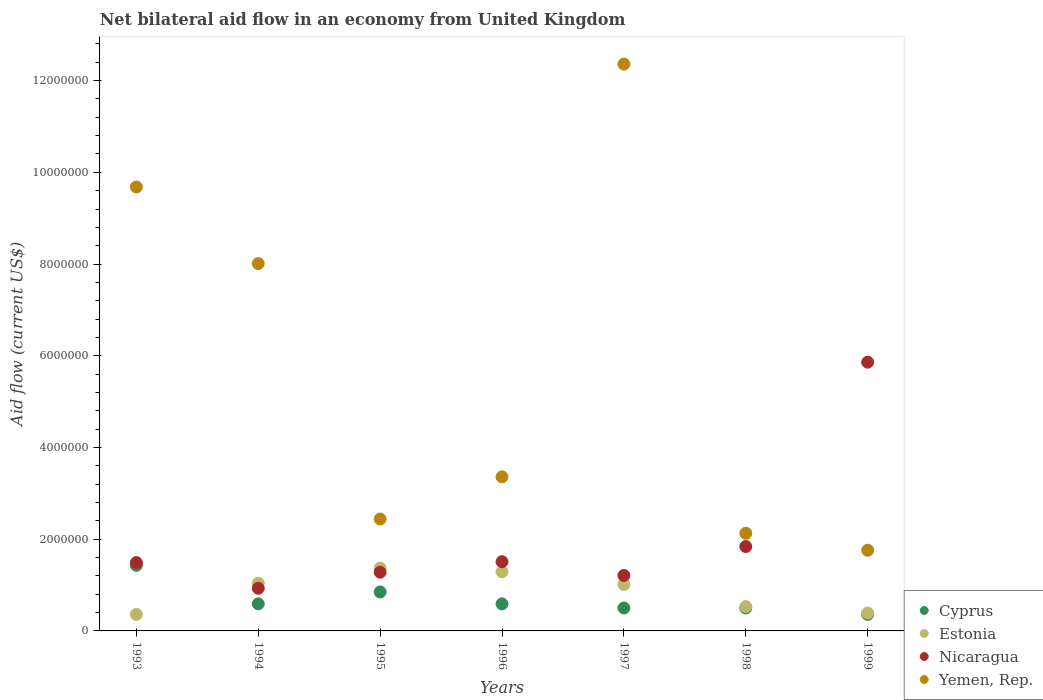How many different coloured dotlines are there?
Offer a terse response. 4. What is the net bilateral aid flow in Yemen, Rep. in 1997?
Offer a terse response. 1.24e+07. Across all years, what is the maximum net bilateral aid flow in Estonia?
Ensure brevity in your answer.  1.37e+06. In which year was the net bilateral aid flow in Estonia maximum?
Make the answer very short. 1995. In which year was the net bilateral aid flow in Yemen, Rep. minimum?
Your response must be concise. 1999. What is the total net bilateral aid flow in Cyprus in the graph?
Your answer should be compact. 4.82e+06. What is the difference between the net bilateral aid flow in Yemen, Rep. in 1996 and that in 1998?
Provide a short and direct response. 1.23e+06. What is the difference between the net bilateral aid flow in Nicaragua in 1998 and the net bilateral aid flow in Estonia in 1999?
Make the answer very short. 1.45e+06. What is the average net bilateral aid flow in Nicaragua per year?
Offer a very short reply. 2.02e+06. In the year 1995, what is the difference between the net bilateral aid flow in Nicaragua and net bilateral aid flow in Estonia?
Ensure brevity in your answer.  -9.00e+04. In how many years, is the net bilateral aid flow in Estonia greater than 1600000 US$?
Ensure brevity in your answer.  0. What is the ratio of the net bilateral aid flow in Yemen, Rep. in 1998 to that in 1999?
Provide a succinct answer. 1.21. Is the net bilateral aid flow in Nicaragua in 1993 less than that in 1997?
Offer a terse response. No. What is the difference between the highest and the second highest net bilateral aid flow in Cyprus?
Provide a succinct answer. 5.80e+05. What is the difference between the highest and the lowest net bilateral aid flow in Yemen, Rep.?
Keep it short and to the point. 1.06e+07. In how many years, is the net bilateral aid flow in Estonia greater than the average net bilateral aid flow in Estonia taken over all years?
Keep it short and to the point. 4. Is it the case that in every year, the sum of the net bilateral aid flow in Nicaragua and net bilateral aid flow in Cyprus  is greater than the sum of net bilateral aid flow in Yemen, Rep. and net bilateral aid flow in Estonia?
Ensure brevity in your answer.  No. Does the net bilateral aid flow in Cyprus monotonically increase over the years?
Give a very brief answer. No. Is the net bilateral aid flow in Estonia strictly greater than the net bilateral aid flow in Nicaragua over the years?
Keep it short and to the point. No. How many dotlines are there?
Give a very brief answer. 4. What is the difference between two consecutive major ticks on the Y-axis?
Your response must be concise. 2.00e+06. Are the values on the major ticks of Y-axis written in scientific E-notation?
Make the answer very short. No. Does the graph contain any zero values?
Your answer should be compact. No. Does the graph contain grids?
Provide a short and direct response. No. Where does the legend appear in the graph?
Your response must be concise. Bottom right. How many legend labels are there?
Keep it short and to the point. 4. How are the legend labels stacked?
Ensure brevity in your answer.  Vertical. What is the title of the graph?
Your response must be concise. Net bilateral aid flow in an economy from United Kingdom. Does "Small states" appear as one of the legend labels in the graph?
Provide a short and direct response. No. What is the label or title of the Y-axis?
Your answer should be very brief. Aid flow (current US$). What is the Aid flow (current US$) of Cyprus in 1993?
Provide a succinct answer. 1.43e+06. What is the Aid flow (current US$) in Estonia in 1993?
Keep it short and to the point. 3.60e+05. What is the Aid flow (current US$) of Nicaragua in 1993?
Make the answer very short. 1.49e+06. What is the Aid flow (current US$) in Yemen, Rep. in 1993?
Ensure brevity in your answer.  9.68e+06. What is the Aid flow (current US$) of Cyprus in 1994?
Provide a succinct answer. 5.90e+05. What is the Aid flow (current US$) in Estonia in 1994?
Your response must be concise. 1.04e+06. What is the Aid flow (current US$) in Nicaragua in 1994?
Offer a terse response. 9.30e+05. What is the Aid flow (current US$) of Yemen, Rep. in 1994?
Give a very brief answer. 8.01e+06. What is the Aid flow (current US$) of Cyprus in 1995?
Offer a terse response. 8.50e+05. What is the Aid flow (current US$) in Estonia in 1995?
Your answer should be very brief. 1.37e+06. What is the Aid flow (current US$) of Nicaragua in 1995?
Provide a succinct answer. 1.28e+06. What is the Aid flow (current US$) in Yemen, Rep. in 1995?
Make the answer very short. 2.44e+06. What is the Aid flow (current US$) in Cyprus in 1996?
Your response must be concise. 5.90e+05. What is the Aid flow (current US$) of Estonia in 1996?
Provide a short and direct response. 1.29e+06. What is the Aid flow (current US$) of Nicaragua in 1996?
Your response must be concise. 1.51e+06. What is the Aid flow (current US$) in Yemen, Rep. in 1996?
Your response must be concise. 3.36e+06. What is the Aid flow (current US$) of Estonia in 1997?
Provide a succinct answer. 1.01e+06. What is the Aid flow (current US$) in Nicaragua in 1997?
Your answer should be very brief. 1.21e+06. What is the Aid flow (current US$) of Yemen, Rep. in 1997?
Offer a terse response. 1.24e+07. What is the Aid flow (current US$) in Estonia in 1998?
Offer a very short reply. 5.30e+05. What is the Aid flow (current US$) in Nicaragua in 1998?
Keep it short and to the point. 1.84e+06. What is the Aid flow (current US$) of Yemen, Rep. in 1998?
Make the answer very short. 2.13e+06. What is the Aid flow (current US$) of Cyprus in 1999?
Give a very brief answer. 3.60e+05. What is the Aid flow (current US$) of Nicaragua in 1999?
Give a very brief answer. 5.86e+06. What is the Aid flow (current US$) of Yemen, Rep. in 1999?
Your answer should be compact. 1.76e+06. Across all years, what is the maximum Aid flow (current US$) of Cyprus?
Your answer should be very brief. 1.43e+06. Across all years, what is the maximum Aid flow (current US$) of Estonia?
Keep it short and to the point. 1.37e+06. Across all years, what is the maximum Aid flow (current US$) of Nicaragua?
Your answer should be compact. 5.86e+06. Across all years, what is the maximum Aid flow (current US$) in Yemen, Rep.?
Give a very brief answer. 1.24e+07. Across all years, what is the minimum Aid flow (current US$) of Estonia?
Ensure brevity in your answer.  3.60e+05. Across all years, what is the minimum Aid flow (current US$) in Nicaragua?
Offer a very short reply. 9.30e+05. Across all years, what is the minimum Aid flow (current US$) in Yemen, Rep.?
Give a very brief answer. 1.76e+06. What is the total Aid flow (current US$) of Cyprus in the graph?
Provide a short and direct response. 4.82e+06. What is the total Aid flow (current US$) in Estonia in the graph?
Offer a terse response. 5.99e+06. What is the total Aid flow (current US$) of Nicaragua in the graph?
Ensure brevity in your answer.  1.41e+07. What is the total Aid flow (current US$) of Yemen, Rep. in the graph?
Offer a very short reply. 3.97e+07. What is the difference between the Aid flow (current US$) in Cyprus in 1993 and that in 1994?
Your response must be concise. 8.40e+05. What is the difference between the Aid flow (current US$) of Estonia in 1993 and that in 1994?
Keep it short and to the point. -6.80e+05. What is the difference between the Aid flow (current US$) in Nicaragua in 1993 and that in 1994?
Your answer should be very brief. 5.60e+05. What is the difference between the Aid flow (current US$) of Yemen, Rep. in 1993 and that in 1994?
Your response must be concise. 1.67e+06. What is the difference between the Aid flow (current US$) in Cyprus in 1993 and that in 1995?
Give a very brief answer. 5.80e+05. What is the difference between the Aid flow (current US$) in Estonia in 1993 and that in 1995?
Provide a short and direct response. -1.01e+06. What is the difference between the Aid flow (current US$) of Nicaragua in 1993 and that in 1995?
Offer a terse response. 2.10e+05. What is the difference between the Aid flow (current US$) of Yemen, Rep. in 1993 and that in 1995?
Make the answer very short. 7.24e+06. What is the difference between the Aid flow (current US$) of Cyprus in 1993 and that in 1996?
Provide a short and direct response. 8.40e+05. What is the difference between the Aid flow (current US$) in Estonia in 1993 and that in 1996?
Keep it short and to the point. -9.30e+05. What is the difference between the Aid flow (current US$) of Nicaragua in 1993 and that in 1996?
Make the answer very short. -2.00e+04. What is the difference between the Aid flow (current US$) of Yemen, Rep. in 1993 and that in 1996?
Provide a short and direct response. 6.32e+06. What is the difference between the Aid flow (current US$) in Cyprus in 1993 and that in 1997?
Keep it short and to the point. 9.30e+05. What is the difference between the Aid flow (current US$) of Estonia in 1993 and that in 1997?
Make the answer very short. -6.50e+05. What is the difference between the Aid flow (current US$) in Nicaragua in 1993 and that in 1997?
Your answer should be very brief. 2.80e+05. What is the difference between the Aid flow (current US$) in Yemen, Rep. in 1993 and that in 1997?
Offer a very short reply. -2.68e+06. What is the difference between the Aid flow (current US$) in Cyprus in 1993 and that in 1998?
Give a very brief answer. 9.30e+05. What is the difference between the Aid flow (current US$) in Estonia in 1993 and that in 1998?
Your answer should be compact. -1.70e+05. What is the difference between the Aid flow (current US$) in Nicaragua in 1993 and that in 1998?
Ensure brevity in your answer.  -3.50e+05. What is the difference between the Aid flow (current US$) in Yemen, Rep. in 1993 and that in 1998?
Ensure brevity in your answer.  7.55e+06. What is the difference between the Aid flow (current US$) in Cyprus in 1993 and that in 1999?
Offer a very short reply. 1.07e+06. What is the difference between the Aid flow (current US$) in Nicaragua in 1993 and that in 1999?
Make the answer very short. -4.37e+06. What is the difference between the Aid flow (current US$) in Yemen, Rep. in 1993 and that in 1999?
Keep it short and to the point. 7.92e+06. What is the difference between the Aid flow (current US$) in Estonia in 1994 and that in 1995?
Give a very brief answer. -3.30e+05. What is the difference between the Aid flow (current US$) of Nicaragua in 1994 and that in 1995?
Your answer should be very brief. -3.50e+05. What is the difference between the Aid flow (current US$) of Yemen, Rep. in 1994 and that in 1995?
Keep it short and to the point. 5.57e+06. What is the difference between the Aid flow (current US$) of Estonia in 1994 and that in 1996?
Provide a short and direct response. -2.50e+05. What is the difference between the Aid flow (current US$) in Nicaragua in 1994 and that in 1996?
Provide a succinct answer. -5.80e+05. What is the difference between the Aid flow (current US$) of Yemen, Rep. in 1994 and that in 1996?
Provide a succinct answer. 4.65e+06. What is the difference between the Aid flow (current US$) in Cyprus in 1994 and that in 1997?
Your answer should be very brief. 9.00e+04. What is the difference between the Aid flow (current US$) in Nicaragua in 1994 and that in 1997?
Keep it short and to the point. -2.80e+05. What is the difference between the Aid flow (current US$) of Yemen, Rep. in 1994 and that in 1997?
Offer a terse response. -4.35e+06. What is the difference between the Aid flow (current US$) of Cyprus in 1994 and that in 1998?
Provide a short and direct response. 9.00e+04. What is the difference between the Aid flow (current US$) in Estonia in 1994 and that in 1998?
Give a very brief answer. 5.10e+05. What is the difference between the Aid flow (current US$) in Nicaragua in 1994 and that in 1998?
Your response must be concise. -9.10e+05. What is the difference between the Aid flow (current US$) in Yemen, Rep. in 1994 and that in 1998?
Ensure brevity in your answer.  5.88e+06. What is the difference between the Aid flow (current US$) in Estonia in 1994 and that in 1999?
Provide a succinct answer. 6.50e+05. What is the difference between the Aid flow (current US$) in Nicaragua in 1994 and that in 1999?
Provide a short and direct response. -4.93e+06. What is the difference between the Aid flow (current US$) of Yemen, Rep. in 1994 and that in 1999?
Give a very brief answer. 6.25e+06. What is the difference between the Aid flow (current US$) of Estonia in 1995 and that in 1996?
Make the answer very short. 8.00e+04. What is the difference between the Aid flow (current US$) of Nicaragua in 1995 and that in 1996?
Your answer should be compact. -2.30e+05. What is the difference between the Aid flow (current US$) in Yemen, Rep. in 1995 and that in 1996?
Your response must be concise. -9.20e+05. What is the difference between the Aid flow (current US$) of Cyprus in 1995 and that in 1997?
Give a very brief answer. 3.50e+05. What is the difference between the Aid flow (current US$) in Nicaragua in 1995 and that in 1997?
Offer a terse response. 7.00e+04. What is the difference between the Aid flow (current US$) in Yemen, Rep. in 1995 and that in 1997?
Your response must be concise. -9.92e+06. What is the difference between the Aid flow (current US$) in Cyprus in 1995 and that in 1998?
Your response must be concise. 3.50e+05. What is the difference between the Aid flow (current US$) in Estonia in 1995 and that in 1998?
Your answer should be very brief. 8.40e+05. What is the difference between the Aid flow (current US$) of Nicaragua in 1995 and that in 1998?
Your answer should be very brief. -5.60e+05. What is the difference between the Aid flow (current US$) in Cyprus in 1995 and that in 1999?
Provide a succinct answer. 4.90e+05. What is the difference between the Aid flow (current US$) of Estonia in 1995 and that in 1999?
Your answer should be compact. 9.80e+05. What is the difference between the Aid flow (current US$) of Nicaragua in 1995 and that in 1999?
Give a very brief answer. -4.58e+06. What is the difference between the Aid flow (current US$) of Yemen, Rep. in 1995 and that in 1999?
Give a very brief answer. 6.80e+05. What is the difference between the Aid flow (current US$) in Nicaragua in 1996 and that in 1997?
Provide a short and direct response. 3.00e+05. What is the difference between the Aid flow (current US$) of Yemen, Rep. in 1996 and that in 1997?
Keep it short and to the point. -9.00e+06. What is the difference between the Aid flow (current US$) in Estonia in 1996 and that in 1998?
Your answer should be compact. 7.60e+05. What is the difference between the Aid flow (current US$) of Nicaragua in 1996 and that in 1998?
Ensure brevity in your answer.  -3.30e+05. What is the difference between the Aid flow (current US$) of Yemen, Rep. in 1996 and that in 1998?
Provide a succinct answer. 1.23e+06. What is the difference between the Aid flow (current US$) in Estonia in 1996 and that in 1999?
Make the answer very short. 9.00e+05. What is the difference between the Aid flow (current US$) of Nicaragua in 1996 and that in 1999?
Make the answer very short. -4.35e+06. What is the difference between the Aid flow (current US$) of Yemen, Rep. in 1996 and that in 1999?
Your response must be concise. 1.60e+06. What is the difference between the Aid flow (current US$) of Nicaragua in 1997 and that in 1998?
Ensure brevity in your answer.  -6.30e+05. What is the difference between the Aid flow (current US$) of Yemen, Rep. in 1997 and that in 1998?
Provide a succinct answer. 1.02e+07. What is the difference between the Aid flow (current US$) of Cyprus in 1997 and that in 1999?
Your response must be concise. 1.40e+05. What is the difference between the Aid flow (current US$) in Estonia in 1997 and that in 1999?
Provide a short and direct response. 6.20e+05. What is the difference between the Aid flow (current US$) in Nicaragua in 1997 and that in 1999?
Offer a very short reply. -4.65e+06. What is the difference between the Aid flow (current US$) of Yemen, Rep. in 1997 and that in 1999?
Give a very brief answer. 1.06e+07. What is the difference between the Aid flow (current US$) of Cyprus in 1998 and that in 1999?
Make the answer very short. 1.40e+05. What is the difference between the Aid flow (current US$) in Nicaragua in 1998 and that in 1999?
Ensure brevity in your answer.  -4.02e+06. What is the difference between the Aid flow (current US$) in Yemen, Rep. in 1998 and that in 1999?
Offer a terse response. 3.70e+05. What is the difference between the Aid flow (current US$) of Cyprus in 1993 and the Aid flow (current US$) of Estonia in 1994?
Your response must be concise. 3.90e+05. What is the difference between the Aid flow (current US$) of Cyprus in 1993 and the Aid flow (current US$) of Yemen, Rep. in 1994?
Offer a very short reply. -6.58e+06. What is the difference between the Aid flow (current US$) of Estonia in 1993 and the Aid flow (current US$) of Nicaragua in 1994?
Your response must be concise. -5.70e+05. What is the difference between the Aid flow (current US$) of Estonia in 1993 and the Aid flow (current US$) of Yemen, Rep. in 1994?
Offer a very short reply. -7.65e+06. What is the difference between the Aid flow (current US$) of Nicaragua in 1993 and the Aid flow (current US$) of Yemen, Rep. in 1994?
Provide a succinct answer. -6.52e+06. What is the difference between the Aid flow (current US$) of Cyprus in 1993 and the Aid flow (current US$) of Yemen, Rep. in 1995?
Offer a very short reply. -1.01e+06. What is the difference between the Aid flow (current US$) of Estonia in 1993 and the Aid flow (current US$) of Nicaragua in 1995?
Offer a terse response. -9.20e+05. What is the difference between the Aid flow (current US$) of Estonia in 1993 and the Aid flow (current US$) of Yemen, Rep. in 1995?
Give a very brief answer. -2.08e+06. What is the difference between the Aid flow (current US$) in Nicaragua in 1993 and the Aid flow (current US$) in Yemen, Rep. in 1995?
Keep it short and to the point. -9.50e+05. What is the difference between the Aid flow (current US$) of Cyprus in 1993 and the Aid flow (current US$) of Nicaragua in 1996?
Your answer should be very brief. -8.00e+04. What is the difference between the Aid flow (current US$) of Cyprus in 1993 and the Aid flow (current US$) of Yemen, Rep. in 1996?
Keep it short and to the point. -1.93e+06. What is the difference between the Aid flow (current US$) of Estonia in 1993 and the Aid flow (current US$) of Nicaragua in 1996?
Provide a succinct answer. -1.15e+06. What is the difference between the Aid flow (current US$) in Estonia in 1993 and the Aid flow (current US$) in Yemen, Rep. in 1996?
Your answer should be very brief. -3.00e+06. What is the difference between the Aid flow (current US$) of Nicaragua in 1993 and the Aid flow (current US$) of Yemen, Rep. in 1996?
Ensure brevity in your answer.  -1.87e+06. What is the difference between the Aid flow (current US$) of Cyprus in 1993 and the Aid flow (current US$) of Estonia in 1997?
Make the answer very short. 4.20e+05. What is the difference between the Aid flow (current US$) of Cyprus in 1993 and the Aid flow (current US$) of Nicaragua in 1997?
Your response must be concise. 2.20e+05. What is the difference between the Aid flow (current US$) of Cyprus in 1993 and the Aid flow (current US$) of Yemen, Rep. in 1997?
Keep it short and to the point. -1.09e+07. What is the difference between the Aid flow (current US$) of Estonia in 1993 and the Aid flow (current US$) of Nicaragua in 1997?
Keep it short and to the point. -8.50e+05. What is the difference between the Aid flow (current US$) of Estonia in 1993 and the Aid flow (current US$) of Yemen, Rep. in 1997?
Your answer should be compact. -1.20e+07. What is the difference between the Aid flow (current US$) in Nicaragua in 1993 and the Aid flow (current US$) in Yemen, Rep. in 1997?
Provide a succinct answer. -1.09e+07. What is the difference between the Aid flow (current US$) in Cyprus in 1993 and the Aid flow (current US$) in Nicaragua in 1998?
Provide a short and direct response. -4.10e+05. What is the difference between the Aid flow (current US$) of Cyprus in 1993 and the Aid flow (current US$) of Yemen, Rep. in 1998?
Offer a terse response. -7.00e+05. What is the difference between the Aid flow (current US$) in Estonia in 1993 and the Aid flow (current US$) in Nicaragua in 1998?
Your answer should be compact. -1.48e+06. What is the difference between the Aid flow (current US$) in Estonia in 1993 and the Aid flow (current US$) in Yemen, Rep. in 1998?
Give a very brief answer. -1.77e+06. What is the difference between the Aid flow (current US$) of Nicaragua in 1993 and the Aid flow (current US$) of Yemen, Rep. in 1998?
Make the answer very short. -6.40e+05. What is the difference between the Aid flow (current US$) of Cyprus in 1993 and the Aid flow (current US$) of Estonia in 1999?
Offer a terse response. 1.04e+06. What is the difference between the Aid flow (current US$) of Cyprus in 1993 and the Aid flow (current US$) of Nicaragua in 1999?
Ensure brevity in your answer.  -4.43e+06. What is the difference between the Aid flow (current US$) in Cyprus in 1993 and the Aid flow (current US$) in Yemen, Rep. in 1999?
Provide a succinct answer. -3.30e+05. What is the difference between the Aid flow (current US$) of Estonia in 1993 and the Aid flow (current US$) of Nicaragua in 1999?
Your answer should be very brief. -5.50e+06. What is the difference between the Aid flow (current US$) in Estonia in 1993 and the Aid flow (current US$) in Yemen, Rep. in 1999?
Provide a succinct answer. -1.40e+06. What is the difference between the Aid flow (current US$) in Nicaragua in 1993 and the Aid flow (current US$) in Yemen, Rep. in 1999?
Make the answer very short. -2.70e+05. What is the difference between the Aid flow (current US$) of Cyprus in 1994 and the Aid flow (current US$) of Estonia in 1995?
Make the answer very short. -7.80e+05. What is the difference between the Aid flow (current US$) of Cyprus in 1994 and the Aid flow (current US$) of Nicaragua in 1995?
Your answer should be compact. -6.90e+05. What is the difference between the Aid flow (current US$) of Cyprus in 1994 and the Aid flow (current US$) of Yemen, Rep. in 1995?
Provide a short and direct response. -1.85e+06. What is the difference between the Aid flow (current US$) in Estonia in 1994 and the Aid flow (current US$) in Nicaragua in 1995?
Ensure brevity in your answer.  -2.40e+05. What is the difference between the Aid flow (current US$) of Estonia in 1994 and the Aid flow (current US$) of Yemen, Rep. in 1995?
Keep it short and to the point. -1.40e+06. What is the difference between the Aid flow (current US$) in Nicaragua in 1994 and the Aid flow (current US$) in Yemen, Rep. in 1995?
Provide a succinct answer. -1.51e+06. What is the difference between the Aid flow (current US$) of Cyprus in 1994 and the Aid flow (current US$) of Estonia in 1996?
Provide a short and direct response. -7.00e+05. What is the difference between the Aid flow (current US$) of Cyprus in 1994 and the Aid flow (current US$) of Nicaragua in 1996?
Make the answer very short. -9.20e+05. What is the difference between the Aid flow (current US$) in Cyprus in 1994 and the Aid flow (current US$) in Yemen, Rep. in 1996?
Your answer should be very brief. -2.77e+06. What is the difference between the Aid flow (current US$) in Estonia in 1994 and the Aid flow (current US$) in Nicaragua in 1996?
Your answer should be very brief. -4.70e+05. What is the difference between the Aid flow (current US$) of Estonia in 1994 and the Aid flow (current US$) of Yemen, Rep. in 1996?
Ensure brevity in your answer.  -2.32e+06. What is the difference between the Aid flow (current US$) in Nicaragua in 1994 and the Aid flow (current US$) in Yemen, Rep. in 1996?
Your response must be concise. -2.43e+06. What is the difference between the Aid flow (current US$) of Cyprus in 1994 and the Aid flow (current US$) of Estonia in 1997?
Offer a terse response. -4.20e+05. What is the difference between the Aid flow (current US$) in Cyprus in 1994 and the Aid flow (current US$) in Nicaragua in 1997?
Offer a very short reply. -6.20e+05. What is the difference between the Aid flow (current US$) of Cyprus in 1994 and the Aid flow (current US$) of Yemen, Rep. in 1997?
Keep it short and to the point. -1.18e+07. What is the difference between the Aid flow (current US$) of Estonia in 1994 and the Aid flow (current US$) of Nicaragua in 1997?
Your answer should be compact. -1.70e+05. What is the difference between the Aid flow (current US$) in Estonia in 1994 and the Aid flow (current US$) in Yemen, Rep. in 1997?
Provide a short and direct response. -1.13e+07. What is the difference between the Aid flow (current US$) in Nicaragua in 1994 and the Aid flow (current US$) in Yemen, Rep. in 1997?
Offer a terse response. -1.14e+07. What is the difference between the Aid flow (current US$) in Cyprus in 1994 and the Aid flow (current US$) in Nicaragua in 1998?
Your answer should be very brief. -1.25e+06. What is the difference between the Aid flow (current US$) in Cyprus in 1994 and the Aid flow (current US$) in Yemen, Rep. in 1998?
Offer a terse response. -1.54e+06. What is the difference between the Aid flow (current US$) of Estonia in 1994 and the Aid flow (current US$) of Nicaragua in 1998?
Make the answer very short. -8.00e+05. What is the difference between the Aid flow (current US$) of Estonia in 1994 and the Aid flow (current US$) of Yemen, Rep. in 1998?
Provide a short and direct response. -1.09e+06. What is the difference between the Aid flow (current US$) in Nicaragua in 1994 and the Aid flow (current US$) in Yemen, Rep. in 1998?
Make the answer very short. -1.20e+06. What is the difference between the Aid flow (current US$) in Cyprus in 1994 and the Aid flow (current US$) in Estonia in 1999?
Keep it short and to the point. 2.00e+05. What is the difference between the Aid flow (current US$) in Cyprus in 1994 and the Aid flow (current US$) in Nicaragua in 1999?
Make the answer very short. -5.27e+06. What is the difference between the Aid flow (current US$) of Cyprus in 1994 and the Aid flow (current US$) of Yemen, Rep. in 1999?
Your response must be concise. -1.17e+06. What is the difference between the Aid flow (current US$) in Estonia in 1994 and the Aid flow (current US$) in Nicaragua in 1999?
Offer a very short reply. -4.82e+06. What is the difference between the Aid flow (current US$) of Estonia in 1994 and the Aid flow (current US$) of Yemen, Rep. in 1999?
Give a very brief answer. -7.20e+05. What is the difference between the Aid flow (current US$) of Nicaragua in 1994 and the Aid flow (current US$) of Yemen, Rep. in 1999?
Provide a short and direct response. -8.30e+05. What is the difference between the Aid flow (current US$) of Cyprus in 1995 and the Aid flow (current US$) of Estonia in 1996?
Make the answer very short. -4.40e+05. What is the difference between the Aid flow (current US$) in Cyprus in 1995 and the Aid flow (current US$) in Nicaragua in 1996?
Provide a succinct answer. -6.60e+05. What is the difference between the Aid flow (current US$) in Cyprus in 1995 and the Aid flow (current US$) in Yemen, Rep. in 1996?
Your answer should be compact. -2.51e+06. What is the difference between the Aid flow (current US$) in Estonia in 1995 and the Aid flow (current US$) in Yemen, Rep. in 1996?
Your answer should be compact. -1.99e+06. What is the difference between the Aid flow (current US$) of Nicaragua in 1995 and the Aid flow (current US$) of Yemen, Rep. in 1996?
Keep it short and to the point. -2.08e+06. What is the difference between the Aid flow (current US$) of Cyprus in 1995 and the Aid flow (current US$) of Nicaragua in 1997?
Make the answer very short. -3.60e+05. What is the difference between the Aid flow (current US$) in Cyprus in 1995 and the Aid flow (current US$) in Yemen, Rep. in 1997?
Offer a terse response. -1.15e+07. What is the difference between the Aid flow (current US$) in Estonia in 1995 and the Aid flow (current US$) in Nicaragua in 1997?
Give a very brief answer. 1.60e+05. What is the difference between the Aid flow (current US$) in Estonia in 1995 and the Aid flow (current US$) in Yemen, Rep. in 1997?
Ensure brevity in your answer.  -1.10e+07. What is the difference between the Aid flow (current US$) of Nicaragua in 1995 and the Aid flow (current US$) of Yemen, Rep. in 1997?
Keep it short and to the point. -1.11e+07. What is the difference between the Aid flow (current US$) in Cyprus in 1995 and the Aid flow (current US$) in Nicaragua in 1998?
Your answer should be compact. -9.90e+05. What is the difference between the Aid flow (current US$) in Cyprus in 1995 and the Aid flow (current US$) in Yemen, Rep. in 1998?
Your answer should be compact. -1.28e+06. What is the difference between the Aid flow (current US$) of Estonia in 1995 and the Aid flow (current US$) of Nicaragua in 1998?
Provide a succinct answer. -4.70e+05. What is the difference between the Aid flow (current US$) of Estonia in 1995 and the Aid flow (current US$) of Yemen, Rep. in 1998?
Offer a very short reply. -7.60e+05. What is the difference between the Aid flow (current US$) of Nicaragua in 1995 and the Aid flow (current US$) of Yemen, Rep. in 1998?
Give a very brief answer. -8.50e+05. What is the difference between the Aid flow (current US$) of Cyprus in 1995 and the Aid flow (current US$) of Estonia in 1999?
Provide a short and direct response. 4.60e+05. What is the difference between the Aid flow (current US$) in Cyprus in 1995 and the Aid flow (current US$) in Nicaragua in 1999?
Your answer should be compact. -5.01e+06. What is the difference between the Aid flow (current US$) in Cyprus in 1995 and the Aid flow (current US$) in Yemen, Rep. in 1999?
Your answer should be compact. -9.10e+05. What is the difference between the Aid flow (current US$) in Estonia in 1995 and the Aid flow (current US$) in Nicaragua in 1999?
Your answer should be compact. -4.49e+06. What is the difference between the Aid flow (current US$) in Estonia in 1995 and the Aid flow (current US$) in Yemen, Rep. in 1999?
Offer a terse response. -3.90e+05. What is the difference between the Aid flow (current US$) of Nicaragua in 1995 and the Aid flow (current US$) of Yemen, Rep. in 1999?
Provide a short and direct response. -4.80e+05. What is the difference between the Aid flow (current US$) in Cyprus in 1996 and the Aid flow (current US$) in Estonia in 1997?
Make the answer very short. -4.20e+05. What is the difference between the Aid flow (current US$) in Cyprus in 1996 and the Aid flow (current US$) in Nicaragua in 1997?
Your answer should be very brief. -6.20e+05. What is the difference between the Aid flow (current US$) of Cyprus in 1996 and the Aid flow (current US$) of Yemen, Rep. in 1997?
Ensure brevity in your answer.  -1.18e+07. What is the difference between the Aid flow (current US$) of Estonia in 1996 and the Aid flow (current US$) of Nicaragua in 1997?
Offer a terse response. 8.00e+04. What is the difference between the Aid flow (current US$) in Estonia in 1996 and the Aid flow (current US$) in Yemen, Rep. in 1997?
Keep it short and to the point. -1.11e+07. What is the difference between the Aid flow (current US$) in Nicaragua in 1996 and the Aid flow (current US$) in Yemen, Rep. in 1997?
Offer a terse response. -1.08e+07. What is the difference between the Aid flow (current US$) in Cyprus in 1996 and the Aid flow (current US$) in Nicaragua in 1998?
Ensure brevity in your answer.  -1.25e+06. What is the difference between the Aid flow (current US$) of Cyprus in 1996 and the Aid flow (current US$) of Yemen, Rep. in 1998?
Keep it short and to the point. -1.54e+06. What is the difference between the Aid flow (current US$) in Estonia in 1996 and the Aid flow (current US$) in Nicaragua in 1998?
Offer a very short reply. -5.50e+05. What is the difference between the Aid flow (current US$) of Estonia in 1996 and the Aid flow (current US$) of Yemen, Rep. in 1998?
Your response must be concise. -8.40e+05. What is the difference between the Aid flow (current US$) in Nicaragua in 1996 and the Aid flow (current US$) in Yemen, Rep. in 1998?
Offer a very short reply. -6.20e+05. What is the difference between the Aid flow (current US$) in Cyprus in 1996 and the Aid flow (current US$) in Estonia in 1999?
Provide a short and direct response. 2.00e+05. What is the difference between the Aid flow (current US$) in Cyprus in 1996 and the Aid flow (current US$) in Nicaragua in 1999?
Offer a very short reply. -5.27e+06. What is the difference between the Aid flow (current US$) of Cyprus in 1996 and the Aid flow (current US$) of Yemen, Rep. in 1999?
Give a very brief answer. -1.17e+06. What is the difference between the Aid flow (current US$) of Estonia in 1996 and the Aid flow (current US$) of Nicaragua in 1999?
Provide a short and direct response. -4.57e+06. What is the difference between the Aid flow (current US$) in Estonia in 1996 and the Aid flow (current US$) in Yemen, Rep. in 1999?
Offer a terse response. -4.70e+05. What is the difference between the Aid flow (current US$) of Nicaragua in 1996 and the Aid flow (current US$) of Yemen, Rep. in 1999?
Provide a succinct answer. -2.50e+05. What is the difference between the Aid flow (current US$) of Cyprus in 1997 and the Aid flow (current US$) of Nicaragua in 1998?
Provide a succinct answer. -1.34e+06. What is the difference between the Aid flow (current US$) of Cyprus in 1997 and the Aid flow (current US$) of Yemen, Rep. in 1998?
Offer a very short reply. -1.63e+06. What is the difference between the Aid flow (current US$) in Estonia in 1997 and the Aid flow (current US$) in Nicaragua in 1998?
Your answer should be compact. -8.30e+05. What is the difference between the Aid flow (current US$) in Estonia in 1997 and the Aid flow (current US$) in Yemen, Rep. in 1998?
Provide a succinct answer. -1.12e+06. What is the difference between the Aid flow (current US$) in Nicaragua in 1997 and the Aid flow (current US$) in Yemen, Rep. in 1998?
Make the answer very short. -9.20e+05. What is the difference between the Aid flow (current US$) of Cyprus in 1997 and the Aid flow (current US$) of Nicaragua in 1999?
Provide a succinct answer. -5.36e+06. What is the difference between the Aid flow (current US$) in Cyprus in 1997 and the Aid flow (current US$) in Yemen, Rep. in 1999?
Your response must be concise. -1.26e+06. What is the difference between the Aid flow (current US$) of Estonia in 1997 and the Aid flow (current US$) of Nicaragua in 1999?
Give a very brief answer. -4.85e+06. What is the difference between the Aid flow (current US$) in Estonia in 1997 and the Aid flow (current US$) in Yemen, Rep. in 1999?
Offer a very short reply. -7.50e+05. What is the difference between the Aid flow (current US$) of Nicaragua in 1997 and the Aid flow (current US$) of Yemen, Rep. in 1999?
Offer a terse response. -5.50e+05. What is the difference between the Aid flow (current US$) of Cyprus in 1998 and the Aid flow (current US$) of Nicaragua in 1999?
Provide a succinct answer. -5.36e+06. What is the difference between the Aid flow (current US$) in Cyprus in 1998 and the Aid flow (current US$) in Yemen, Rep. in 1999?
Give a very brief answer. -1.26e+06. What is the difference between the Aid flow (current US$) in Estonia in 1998 and the Aid flow (current US$) in Nicaragua in 1999?
Provide a succinct answer. -5.33e+06. What is the difference between the Aid flow (current US$) of Estonia in 1998 and the Aid flow (current US$) of Yemen, Rep. in 1999?
Offer a very short reply. -1.23e+06. What is the difference between the Aid flow (current US$) in Nicaragua in 1998 and the Aid flow (current US$) in Yemen, Rep. in 1999?
Make the answer very short. 8.00e+04. What is the average Aid flow (current US$) of Cyprus per year?
Offer a terse response. 6.89e+05. What is the average Aid flow (current US$) of Estonia per year?
Offer a very short reply. 8.56e+05. What is the average Aid flow (current US$) in Nicaragua per year?
Offer a very short reply. 2.02e+06. What is the average Aid flow (current US$) in Yemen, Rep. per year?
Your response must be concise. 5.68e+06. In the year 1993, what is the difference between the Aid flow (current US$) of Cyprus and Aid flow (current US$) of Estonia?
Provide a succinct answer. 1.07e+06. In the year 1993, what is the difference between the Aid flow (current US$) in Cyprus and Aid flow (current US$) in Yemen, Rep.?
Your answer should be compact. -8.25e+06. In the year 1993, what is the difference between the Aid flow (current US$) in Estonia and Aid flow (current US$) in Nicaragua?
Give a very brief answer. -1.13e+06. In the year 1993, what is the difference between the Aid flow (current US$) in Estonia and Aid flow (current US$) in Yemen, Rep.?
Give a very brief answer. -9.32e+06. In the year 1993, what is the difference between the Aid flow (current US$) of Nicaragua and Aid flow (current US$) of Yemen, Rep.?
Ensure brevity in your answer.  -8.19e+06. In the year 1994, what is the difference between the Aid flow (current US$) in Cyprus and Aid flow (current US$) in Estonia?
Offer a very short reply. -4.50e+05. In the year 1994, what is the difference between the Aid flow (current US$) of Cyprus and Aid flow (current US$) of Nicaragua?
Provide a succinct answer. -3.40e+05. In the year 1994, what is the difference between the Aid flow (current US$) of Cyprus and Aid flow (current US$) of Yemen, Rep.?
Offer a terse response. -7.42e+06. In the year 1994, what is the difference between the Aid flow (current US$) in Estonia and Aid flow (current US$) in Yemen, Rep.?
Your answer should be very brief. -6.97e+06. In the year 1994, what is the difference between the Aid flow (current US$) of Nicaragua and Aid flow (current US$) of Yemen, Rep.?
Provide a succinct answer. -7.08e+06. In the year 1995, what is the difference between the Aid flow (current US$) of Cyprus and Aid flow (current US$) of Estonia?
Your answer should be very brief. -5.20e+05. In the year 1995, what is the difference between the Aid flow (current US$) in Cyprus and Aid flow (current US$) in Nicaragua?
Ensure brevity in your answer.  -4.30e+05. In the year 1995, what is the difference between the Aid flow (current US$) of Cyprus and Aid flow (current US$) of Yemen, Rep.?
Keep it short and to the point. -1.59e+06. In the year 1995, what is the difference between the Aid flow (current US$) in Estonia and Aid flow (current US$) in Nicaragua?
Provide a succinct answer. 9.00e+04. In the year 1995, what is the difference between the Aid flow (current US$) in Estonia and Aid flow (current US$) in Yemen, Rep.?
Provide a succinct answer. -1.07e+06. In the year 1995, what is the difference between the Aid flow (current US$) in Nicaragua and Aid flow (current US$) in Yemen, Rep.?
Make the answer very short. -1.16e+06. In the year 1996, what is the difference between the Aid flow (current US$) of Cyprus and Aid flow (current US$) of Estonia?
Your answer should be very brief. -7.00e+05. In the year 1996, what is the difference between the Aid flow (current US$) in Cyprus and Aid flow (current US$) in Nicaragua?
Ensure brevity in your answer.  -9.20e+05. In the year 1996, what is the difference between the Aid flow (current US$) in Cyprus and Aid flow (current US$) in Yemen, Rep.?
Provide a succinct answer. -2.77e+06. In the year 1996, what is the difference between the Aid flow (current US$) in Estonia and Aid flow (current US$) in Nicaragua?
Make the answer very short. -2.20e+05. In the year 1996, what is the difference between the Aid flow (current US$) in Estonia and Aid flow (current US$) in Yemen, Rep.?
Provide a short and direct response. -2.07e+06. In the year 1996, what is the difference between the Aid flow (current US$) of Nicaragua and Aid flow (current US$) of Yemen, Rep.?
Offer a terse response. -1.85e+06. In the year 1997, what is the difference between the Aid flow (current US$) in Cyprus and Aid flow (current US$) in Estonia?
Your answer should be compact. -5.10e+05. In the year 1997, what is the difference between the Aid flow (current US$) of Cyprus and Aid flow (current US$) of Nicaragua?
Make the answer very short. -7.10e+05. In the year 1997, what is the difference between the Aid flow (current US$) in Cyprus and Aid flow (current US$) in Yemen, Rep.?
Provide a short and direct response. -1.19e+07. In the year 1997, what is the difference between the Aid flow (current US$) of Estonia and Aid flow (current US$) of Yemen, Rep.?
Your answer should be very brief. -1.14e+07. In the year 1997, what is the difference between the Aid flow (current US$) in Nicaragua and Aid flow (current US$) in Yemen, Rep.?
Offer a very short reply. -1.12e+07. In the year 1998, what is the difference between the Aid flow (current US$) of Cyprus and Aid flow (current US$) of Nicaragua?
Your answer should be very brief. -1.34e+06. In the year 1998, what is the difference between the Aid flow (current US$) in Cyprus and Aid flow (current US$) in Yemen, Rep.?
Ensure brevity in your answer.  -1.63e+06. In the year 1998, what is the difference between the Aid flow (current US$) in Estonia and Aid flow (current US$) in Nicaragua?
Make the answer very short. -1.31e+06. In the year 1998, what is the difference between the Aid flow (current US$) in Estonia and Aid flow (current US$) in Yemen, Rep.?
Offer a very short reply. -1.60e+06. In the year 1998, what is the difference between the Aid flow (current US$) in Nicaragua and Aid flow (current US$) in Yemen, Rep.?
Make the answer very short. -2.90e+05. In the year 1999, what is the difference between the Aid flow (current US$) of Cyprus and Aid flow (current US$) of Nicaragua?
Provide a short and direct response. -5.50e+06. In the year 1999, what is the difference between the Aid flow (current US$) of Cyprus and Aid flow (current US$) of Yemen, Rep.?
Make the answer very short. -1.40e+06. In the year 1999, what is the difference between the Aid flow (current US$) of Estonia and Aid flow (current US$) of Nicaragua?
Provide a succinct answer. -5.47e+06. In the year 1999, what is the difference between the Aid flow (current US$) in Estonia and Aid flow (current US$) in Yemen, Rep.?
Give a very brief answer. -1.37e+06. In the year 1999, what is the difference between the Aid flow (current US$) in Nicaragua and Aid flow (current US$) in Yemen, Rep.?
Your answer should be compact. 4.10e+06. What is the ratio of the Aid flow (current US$) of Cyprus in 1993 to that in 1994?
Your response must be concise. 2.42. What is the ratio of the Aid flow (current US$) in Estonia in 1993 to that in 1994?
Your answer should be compact. 0.35. What is the ratio of the Aid flow (current US$) of Nicaragua in 1993 to that in 1994?
Your response must be concise. 1.6. What is the ratio of the Aid flow (current US$) in Yemen, Rep. in 1993 to that in 1994?
Provide a succinct answer. 1.21. What is the ratio of the Aid flow (current US$) of Cyprus in 1993 to that in 1995?
Your answer should be compact. 1.68. What is the ratio of the Aid flow (current US$) in Estonia in 1993 to that in 1995?
Offer a very short reply. 0.26. What is the ratio of the Aid flow (current US$) in Nicaragua in 1993 to that in 1995?
Provide a short and direct response. 1.16. What is the ratio of the Aid flow (current US$) in Yemen, Rep. in 1993 to that in 1995?
Offer a very short reply. 3.97. What is the ratio of the Aid flow (current US$) in Cyprus in 1993 to that in 1996?
Offer a terse response. 2.42. What is the ratio of the Aid flow (current US$) in Estonia in 1993 to that in 1996?
Provide a short and direct response. 0.28. What is the ratio of the Aid flow (current US$) in Yemen, Rep. in 1993 to that in 1996?
Offer a terse response. 2.88. What is the ratio of the Aid flow (current US$) in Cyprus in 1993 to that in 1997?
Offer a very short reply. 2.86. What is the ratio of the Aid flow (current US$) in Estonia in 1993 to that in 1997?
Provide a succinct answer. 0.36. What is the ratio of the Aid flow (current US$) of Nicaragua in 1993 to that in 1997?
Ensure brevity in your answer.  1.23. What is the ratio of the Aid flow (current US$) of Yemen, Rep. in 1993 to that in 1997?
Your answer should be very brief. 0.78. What is the ratio of the Aid flow (current US$) of Cyprus in 1993 to that in 1998?
Offer a terse response. 2.86. What is the ratio of the Aid flow (current US$) of Estonia in 1993 to that in 1998?
Make the answer very short. 0.68. What is the ratio of the Aid flow (current US$) of Nicaragua in 1993 to that in 1998?
Ensure brevity in your answer.  0.81. What is the ratio of the Aid flow (current US$) in Yemen, Rep. in 1993 to that in 1998?
Keep it short and to the point. 4.54. What is the ratio of the Aid flow (current US$) in Cyprus in 1993 to that in 1999?
Keep it short and to the point. 3.97. What is the ratio of the Aid flow (current US$) of Nicaragua in 1993 to that in 1999?
Give a very brief answer. 0.25. What is the ratio of the Aid flow (current US$) of Cyprus in 1994 to that in 1995?
Provide a short and direct response. 0.69. What is the ratio of the Aid flow (current US$) in Estonia in 1994 to that in 1995?
Offer a terse response. 0.76. What is the ratio of the Aid flow (current US$) in Nicaragua in 1994 to that in 1995?
Your response must be concise. 0.73. What is the ratio of the Aid flow (current US$) in Yemen, Rep. in 1994 to that in 1995?
Your answer should be very brief. 3.28. What is the ratio of the Aid flow (current US$) of Estonia in 1994 to that in 1996?
Provide a succinct answer. 0.81. What is the ratio of the Aid flow (current US$) in Nicaragua in 1994 to that in 1996?
Give a very brief answer. 0.62. What is the ratio of the Aid flow (current US$) of Yemen, Rep. in 1994 to that in 1996?
Provide a short and direct response. 2.38. What is the ratio of the Aid flow (current US$) in Cyprus in 1994 to that in 1997?
Ensure brevity in your answer.  1.18. What is the ratio of the Aid flow (current US$) in Estonia in 1994 to that in 1997?
Your response must be concise. 1.03. What is the ratio of the Aid flow (current US$) in Nicaragua in 1994 to that in 1997?
Provide a short and direct response. 0.77. What is the ratio of the Aid flow (current US$) of Yemen, Rep. in 1994 to that in 1997?
Provide a succinct answer. 0.65. What is the ratio of the Aid flow (current US$) in Cyprus in 1994 to that in 1998?
Your response must be concise. 1.18. What is the ratio of the Aid flow (current US$) in Estonia in 1994 to that in 1998?
Give a very brief answer. 1.96. What is the ratio of the Aid flow (current US$) of Nicaragua in 1994 to that in 1998?
Offer a very short reply. 0.51. What is the ratio of the Aid flow (current US$) of Yemen, Rep. in 1994 to that in 1998?
Ensure brevity in your answer.  3.76. What is the ratio of the Aid flow (current US$) in Cyprus in 1994 to that in 1999?
Your answer should be compact. 1.64. What is the ratio of the Aid flow (current US$) of Estonia in 1994 to that in 1999?
Your response must be concise. 2.67. What is the ratio of the Aid flow (current US$) in Nicaragua in 1994 to that in 1999?
Offer a terse response. 0.16. What is the ratio of the Aid flow (current US$) in Yemen, Rep. in 1994 to that in 1999?
Your response must be concise. 4.55. What is the ratio of the Aid flow (current US$) of Cyprus in 1995 to that in 1996?
Provide a short and direct response. 1.44. What is the ratio of the Aid flow (current US$) of Estonia in 1995 to that in 1996?
Give a very brief answer. 1.06. What is the ratio of the Aid flow (current US$) in Nicaragua in 1995 to that in 1996?
Your answer should be very brief. 0.85. What is the ratio of the Aid flow (current US$) in Yemen, Rep. in 1995 to that in 1996?
Give a very brief answer. 0.73. What is the ratio of the Aid flow (current US$) in Cyprus in 1995 to that in 1997?
Your response must be concise. 1.7. What is the ratio of the Aid flow (current US$) of Estonia in 1995 to that in 1997?
Ensure brevity in your answer.  1.36. What is the ratio of the Aid flow (current US$) in Nicaragua in 1995 to that in 1997?
Provide a short and direct response. 1.06. What is the ratio of the Aid flow (current US$) of Yemen, Rep. in 1995 to that in 1997?
Provide a short and direct response. 0.2. What is the ratio of the Aid flow (current US$) of Cyprus in 1995 to that in 1998?
Provide a succinct answer. 1.7. What is the ratio of the Aid flow (current US$) of Estonia in 1995 to that in 1998?
Give a very brief answer. 2.58. What is the ratio of the Aid flow (current US$) in Nicaragua in 1995 to that in 1998?
Your response must be concise. 0.7. What is the ratio of the Aid flow (current US$) in Yemen, Rep. in 1995 to that in 1998?
Offer a terse response. 1.15. What is the ratio of the Aid flow (current US$) of Cyprus in 1995 to that in 1999?
Ensure brevity in your answer.  2.36. What is the ratio of the Aid flow (current US$) of Estonia in 1995 to that in 1999?
Ensure brevity in your answer.  3.51. What is the ratio of the Aid flow (current US$) of Nicaragua in 1995 to that in 1999?
Your answer should be very brief. 0.22. What is the ratio of the Aid flow (current US$) of Yemen, Rep. in 1995 to that in 1999?
Give a very brief answer. 1.39. What is the ratio of the Aid flow (current US$) of Cyprus in 1996 to that in 1997?
Make the answer very short. 1.18. What is the ratio of the Aid flow (current US$) of Estonia in 1996 to that in 1997?
Your answer should be very brief. 1.28. What is the ratio of the Aid flow (current US$) of Nicaragua in 1996 to that in 1997?
Your response must be concise. 1.25. What is the ratio of the Aid flow (current US$) in Yemen, Rep. in 1996 to that in 1997?
Keep it short and to the point. 0.27. What is the ratio of the Aid flow (current US$) of Cyprus in 1996 to that in 1998?
Make the answer very short. 1.18. What is the ratio of the Aid flow (current US$) of Estonia in 1996 to that in 1998?
Keep it short and to the point. 2.43. What is the ratio of the Aid flow (current US$) of Nicaragua in 1996 to that in 1998?
Make the answer very short. 0.82. What is the ratio of the Aid flow (current US$) of Yemen, Rep. in 1996 to that in 1998?
Ensure brevity in your answer.  1.58. What is the ratio of the Aid flow (current US$) in Cyprus in 1996 to that in 1999?
Ensure brevity in your answer.  1.64. What is the ratio of the Aid flow (current US$) in Estonia in 1996 to that in 1999?
Your response must be concise. 3.31. What is the ratio of the Aid flow (current US$) in Nicaragua in 1996 to that in 1999?
Provide a short and direct response. 0.26. What is the ratio of the Aid flow (current US$) in Yemen, Rep. in 1996 to that in 1999?
Your answer should be very brief. 1.91. What is the ratio of the Aid flow (current US$) of Estonia in 1997 to that in 1998?
Ensure brevity in your answer.  1.91. What is the ratio of the Aid flow (current US$) of Nicaragua in 1997 to that in 1998?
Your response must be concise. 0.66. What is the ratio of the Aid flow (current US$) of Yemen, Rep. in 1997 to that in 1998?
Provide a short and direct response. 5.8. What is the ratio of the Aid flow (current US$) of Cyprus in 1997 to that in 1999?
Your answer should be very brief. 1.39. What is the ratio of the Aid flow (current US$) in Estonia in 1997 to that in 1999?
Your answer should be compact. 2.59. What is the ratio of the Aid flow (current US$) of Nicaragua in 1997 to that in 1999?
Offer a terse response. 0.21. What is the ratio of the Aid flow (current US$) of Yemen, Rep. in 1997 to that in 1999?
Give a very brief answer. 7.02. What is the ratio of the Aid flow (current US$) of Cyprus in 1998 to that in 1999?
Provide a short and direct response. 1.39. What is the ratio of the Aid flow (current US$) of Estonia in 1998 to that in 1999?
Ensure brevity in your answer.  1.36. What is the ratio of the Aid flow (current US$) in Nicaragua in 1998 to that in 1999?
Your answer should be very brief. 0.31. What is the ratio of the Aid flow (current US$) of Yemen, Rep. in 1998 to that in 1999?
Your answer should be compact. 1.21. What is the difference between the highest and the second highest Aid flow (current US$) of Cyprus?
Offer a very short reply. 5.80e+05. What is the difference between the highest and the second highest Aid flow (current US$) in Estonia?
Your answer should be compact. 8.00e+04. What is the difference between the highest and the second highest Aid flow (current US$) in Nicaragua?
Your answer should be very brief. 4.02e+06. What is the difference between the highest and the second highest Aid flow (current US$) in Yemen, Rep.?
Provide a succinct answer. 2.68e+06. What is the difference between the highest and the lowest Aid flow (current US$) of Cyprus?
Ensure brevity in your answer.  1.07e+06. What is the difference between the highest and the lowest Aid flow (current US$) of Estonia?
Offer a terse response. 1.01e+06. What is the difference between the highest and the lowest Aid flow (current US$) in Nicaragua?
Give a very brief answer. 4.93e+06. What is the difference between the highest and the lowest Aid flow (current US$) of Yemen, Rep.?
Offer a very short reply. 1.06e+07. 